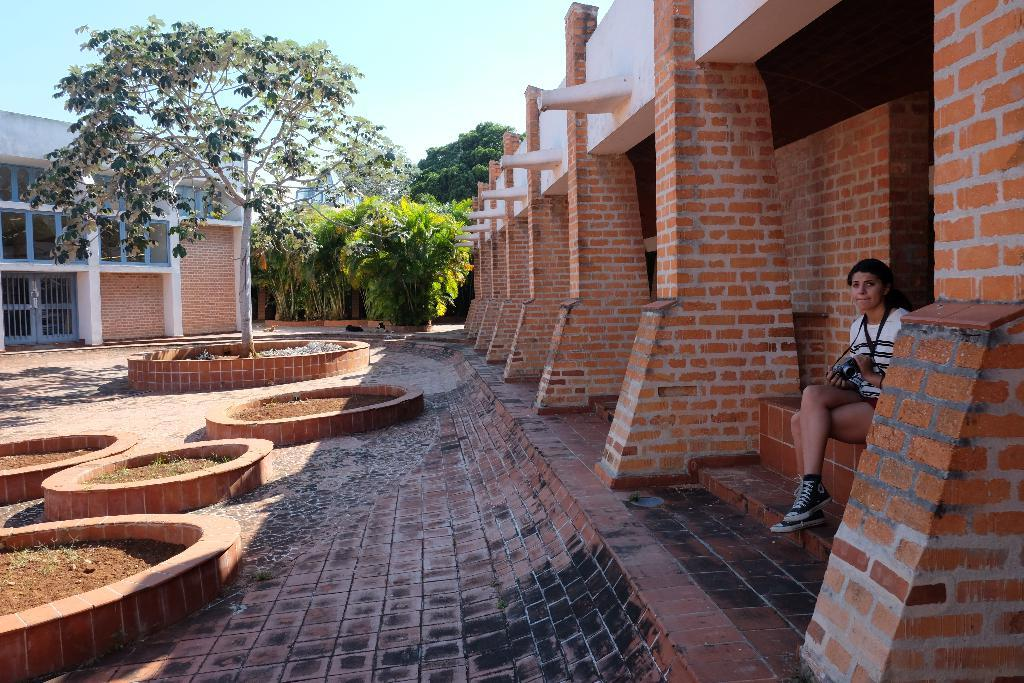What is the person in the image doing? The person is sitting on the stairs. What type of protective gear is the person wearing? The person is wearing a helmet around their neck. What type of vegetation can be seen in the image? There are trees visible in the image. What type of architectural features can be seen in the image? There are doors and windows visible in the image. What is visible in the background of the image? The sky is visible in the image. What type of wood is the airport made of in the image? There is no airport present in the image, so it is not possible to determine what type of wood it might be made of. What type of fowl can be seen flying in the image? There are no birds or fowl visible in the image. 